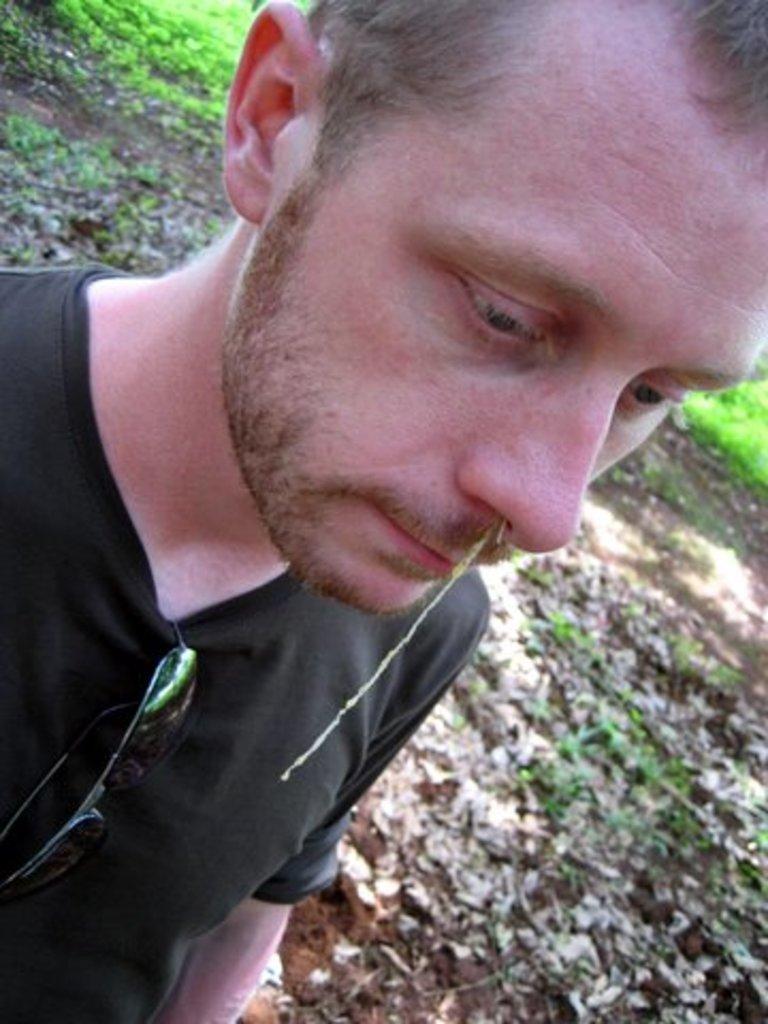How would you summarize this image in a sentence or two? In the picture we can see a man standing on the mud path, wearing a black T-shirt and shades handed to it and behind him we can see a grass surface. 